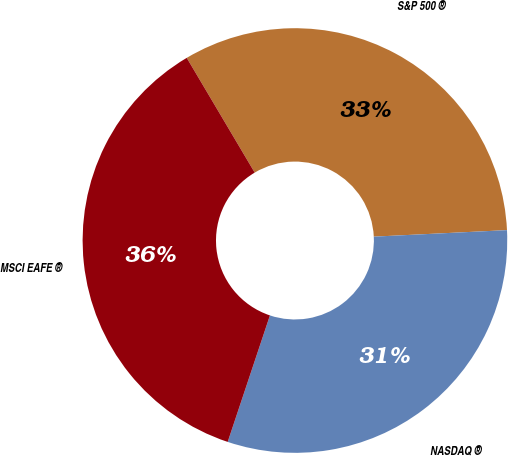Convert chart to OTSL. <chart><loc_0><loc_0><loc_500><loc_500><pie_chart><fcel>S&P 500 ®<fcel>NASDAQ ®<fcel>MSCI EAFE ®<nl><fcel>32.73%<fcel>30.91%<fcel>36.36%<nl></chart> 